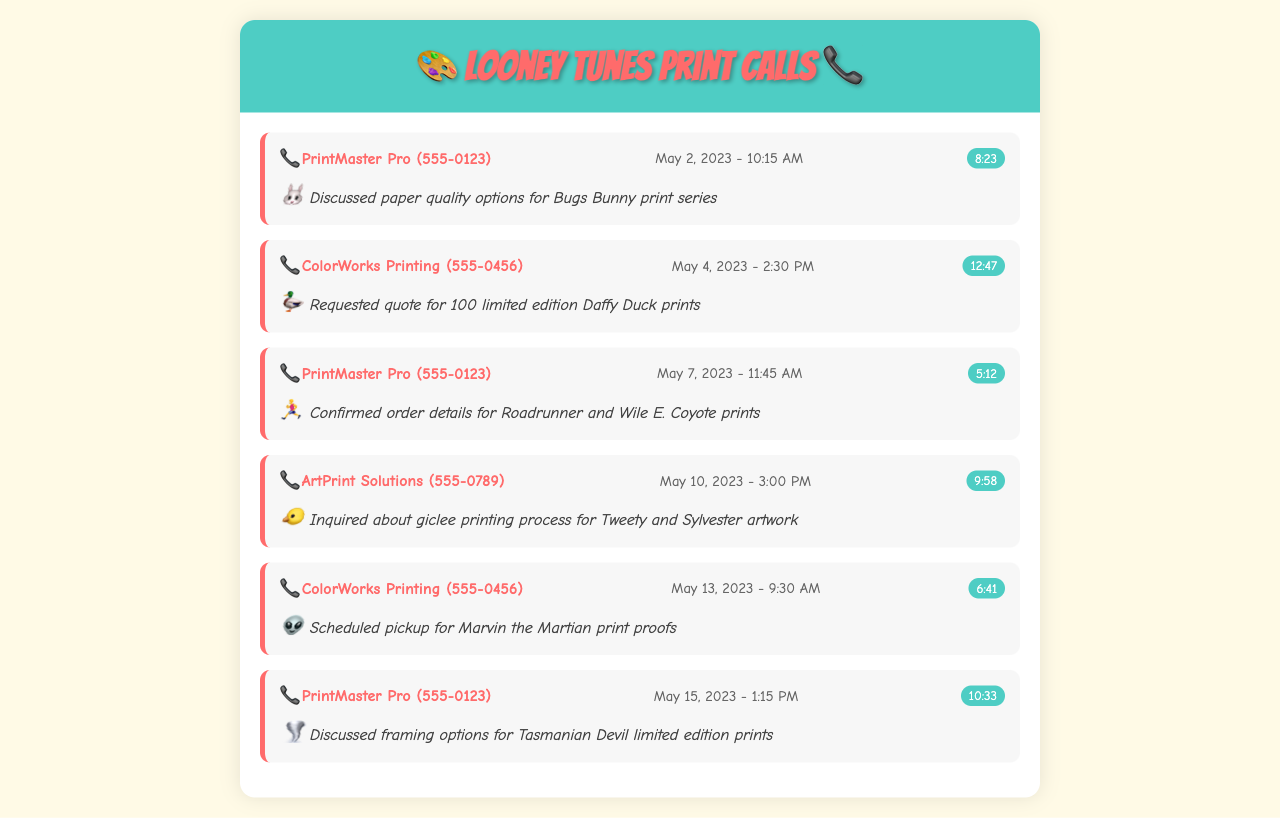what is the first printing company contacted? The first printing company mentioned in the records is listed in the first record under "contact."
Answer: PrintMaster Pro what was the date of the call to ColorWorks Printing regarding the Daffy Duck prints? The date can be found in the second record in the document.
Answer: May 4, 2023 how long was the call discussing paper quality options? The duration of the first call about paper quality options is provided in the first record.
Answer: 8:23 how many limited edition prints were requested for Daffy Duck? The specific number of prints requested is noted in the second record.
Answer: 100 which print company was contacted on May 15, 2023? This question pertains to the date in the last record of the document.
Answer: PrintMaster Pro what topic was discussed during the call about framing options? The last record notes this specific topic discussed during the call.
Answer: framing options for Tasmanian Devil how many calls were made to PrintMaster Pro? Count the occurrences of "PrintMaster Pro" in the document's records.
Answer: 3 what character is associated with the inquiry about the giclee printing process? The character related to the giclee printing process can be found in the notes of the fourth record.
Answer: Tweety and Sylvester when was the scheduled pickup for Marvin the Martian print proofs? The date for this scheduled pickup is mentioned in the fifth record.
Answer: May 13, 2023 